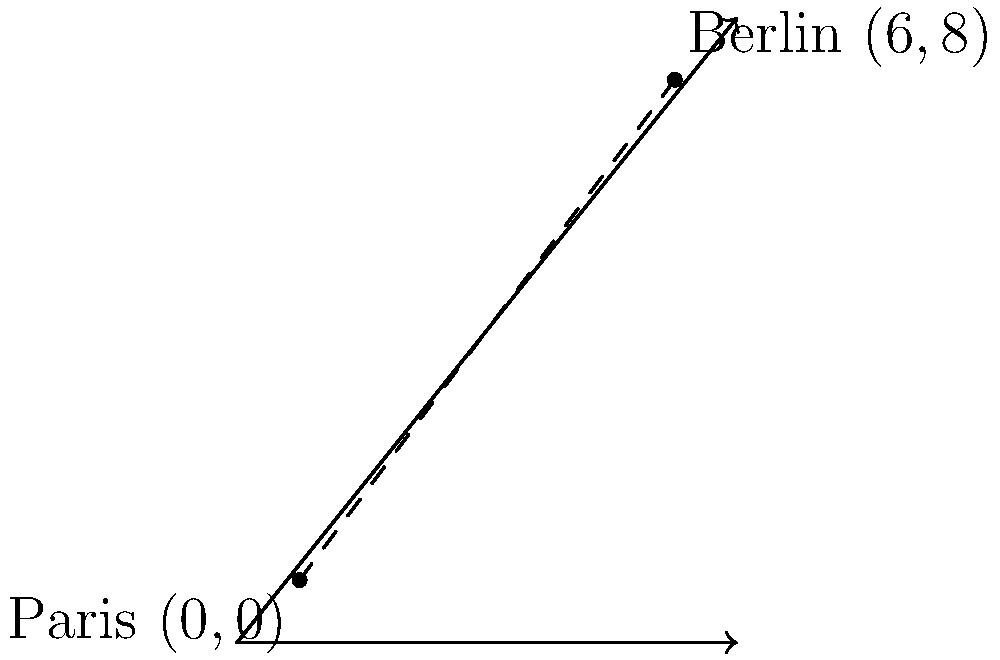As a former diplomat, you're reminiscing about your travels between European capitals. On a coordinate plane where each unit represents 100 km, Paris is located at $(0,0)$ and Berlin at $(6,8)$. Using the distance formula, calculate the direct distance between these two cities in kilometers. To solve this problem, we'll use the distance formula derived from the Pythagorean theorem:

$d = \sqrt{(x_2-x_1)^2 + (y_2-y_1)^2}$

Where:
$(x_1,y_1)$ is the coordinate of Paris $(0,0)$
$(x_2,y_2)$ is the coordinate of Berlin $(6,8)$

Step 1: Substitute the values into the formula:
$d = \sqrt{(6-0)^2 + (8-0)^2}$

Step 2: Simplify inside the parentheses:
$d = \sqrt{6^2 + 8^2}$

Step 3: Calculate the squares:
$d = \sqrt{36 + 64}$

Step 4: Add inside the square root:
$d = \sqrt{100}$

Step 5: Simplify the square root:
$d = 10$

Step 6: Recall that each unit represents 100 km:
$10 \times 100 = 1000$ km

Therefore, the direct distance between Paris and Berlin is 1000 km.
Answer: 1000 km 